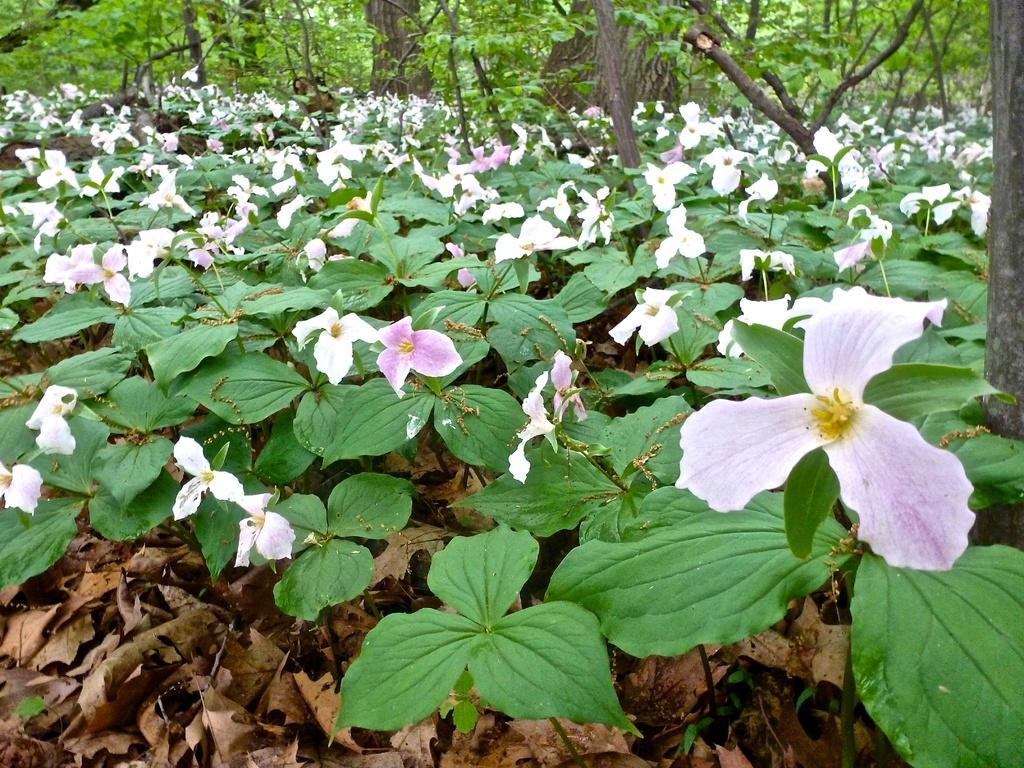What type of plants can be seen on the ground in the image? There are plants with flowers on the ground in the image. What is the condition of the leaves on the plants? There are dried leaves visible in the image. What can be seen in the background of the image? There are trees in the background of the image. How many jewels can be seen on the plants in the image? There are no jewels present on the plants in the image. What type of soap is being used to clean the leaves in the image? There is no soap or cleaning activity depicted in the image. 